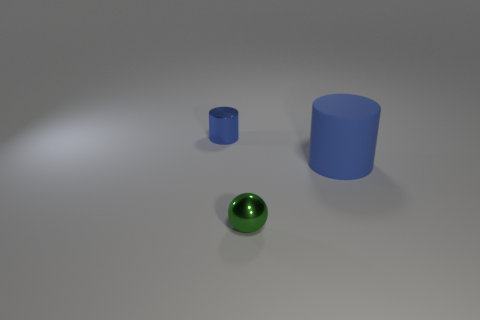Add 1 cylinders. How many objects exist? 4 Subtract all balls. How many objects are left? 2 Subtract all shiny cylinders. Subtract all green shiny spheres. How many objects are left? 1 Add 3 small spheres. How many small spheres are left? 4 Add 3 green metal objects. How many green metal objects exist? 4 Subtract 1 green spheres. How many objects are left? 2 Subtract all gray balls. Subtract all yellow cylinders. How many balls are left? 1 